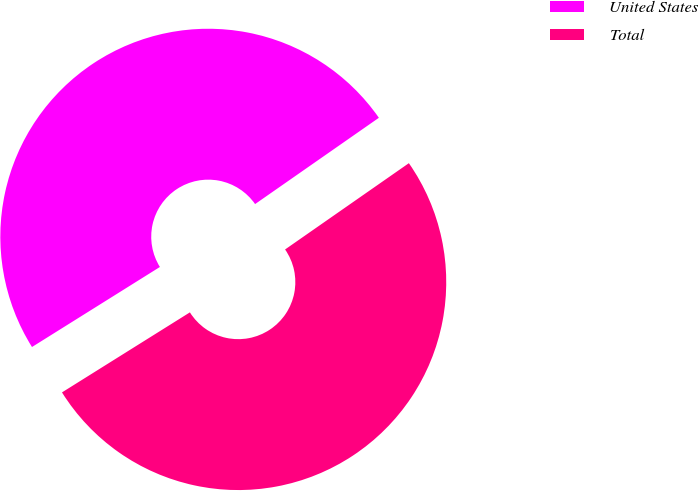<chart> <loc_0><loc_0><loc_500><loc_500><pie_chart><fcel>United States<fcel>Total<nl><fcel>49.21%<fcel>50.79%<nl></chart> 